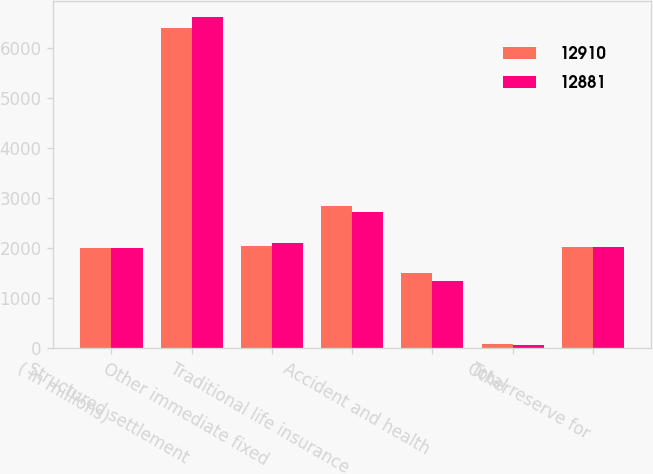<chart> <loc_0><loc_0><loc_500><loc_500><stacked_bar_chart><ecel><fcel>( in millions)<fcel>Structured settlement<fcel>Other immediate fixed<fcel>Traditional life insurance<fcel>Accident and health<fcel>Other<fcel>Total reserve for<nl><fcel>12910<fcel>2009<fcel>6406<fcel>2048<fcel>2850<fcel>1514<fcel>92<fcel>2028.5<nl><fcel>12881<fcel>2008<fcel>6628<fcel>2106<fcel>2723<fcel>1355<fcel>69<fcel>2028.5<nl></chart> 